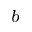<formula> <loc_0><loc_0><loc_500><loc_500>^ { b }</formula> 